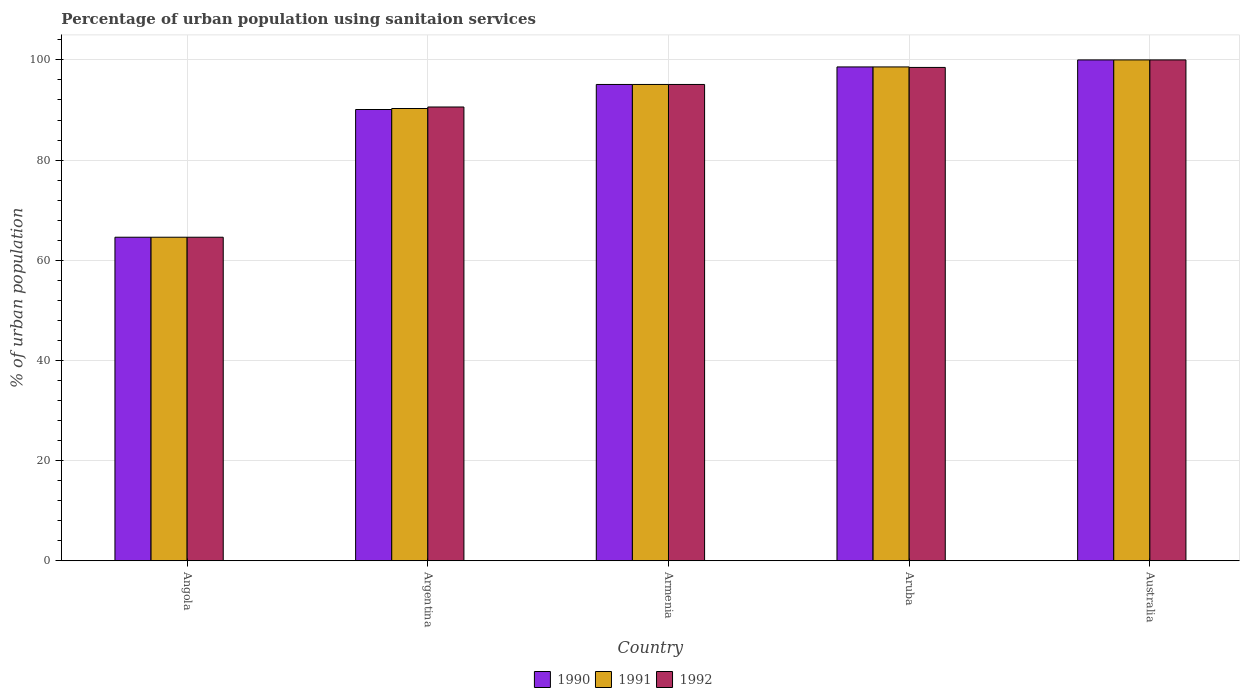How many different coloured bars are there?
Your answer should be very brief. 3. Are the number of bars per tick equal to the number of legend labels?
Your answer should be compact. Yes. Are the number of bars on each tick of the X-axis equal?
Your answer should be compact. Yes. How many bars are there on the 5th tick from the right?
Make the answer very short. 3. What is the label of the 2nd group of bars from the left?
Your response must be concise. Argentina. What is the percentage of urban population using sanitaion services in 1990 in Armenia?
Provide a short and direct response. 95.1. Across all countries, what is the maximum percentage of urban population using sanitaion services in 1990?
Give a very brief answer. 100. Across all countries, what is the minimum percentage of urban population using sanitaion services in 1990?
Offer a very short reply. 64.6. In which country was the percentage of urban population using sanitaion services in 1992 maximum?
Offer a very short reply. Australia. In which country was the percentage of urban population using sanitaion services in 1992 minimum?
Keep it short and to the point. Angola. What is the total percentage of urban population using sanitaion services in 1991 in the graph?
Give a very brief answer. 448.6. What is the difference between the percentage of urban population using sanitaion services in 1992 in Angola and that in Australia?
Your response must be concise. -35.4. What is the difference between the percentage of urban population using sanitaion services in 1990 in Argentina and the percentage of urban population using sanitaion services in 1992 in Angola?
Provide a short and direct response. 25.5. What is the average percentage of urban population using sanitaion services in 1992 per country?
Your answer should be compact. 89.76. What is the difference between the percentage of urban population using sanitaion services of/in 1990 and percentage of urban population using sanitaion services of/in 1992 in Argentina?
Offer a very short reply. -0.5. In how many countries, is the percentage of urban population using sanitaion services in 1991 greater than 56 %?
Keep it short and to the point. 5. What is the ratio of the percentage of urban population using sanitaion services in 1990 in Argentina to that in Australia?
Your answer should be very brief. 0.9. Is the percentage of urban population using sanitaion services in 1990 in Angola less than that in Armenia?
Your response must be concise. Yes. Is the difference between the percentage of urban population using sanitaion services in 1990 in Argentina and Aruba greater than the difference between the percentage of urban population using sanitaion services in 1992 in Argentina and Aruba?
Provide a succinct answer. No. What is the difference between the highest and the second highest percentage of urban population using sanitaion services in 1990?
Ensure brevity in your answer.  -1.4. What is the difference between the highest and the lowest percentage of urban population using sanitaion services in 1990?
Keep it short and to the point. 35.4. Are all the bars in the graph horizontal?
Keep it short and to the point. No. How many countries are there in the graph?
Keep it short and to the point. 5. Does the graph contain grids?
Keep it short and to the point. Yes. Where does the legend appear in the graph?
Keep it short and to the point. Bottom center. What is the title of the graph?
Make the answer very short. Percentage of urban population using sanitaion services. Does "1984" appear as one of the legend labels in the graph?
Ensure brevity in your answer.  No. What is the label or title of the Y-axis?
Make the answer very short. % of urban population. What is the % of urban population of 1990 in Angola?
Make the answer very short. 64.6. What is the % of urban population of 1991 in Angola?
Keep it short and to the point. 64.6. What is the % of urban population of 1992 in Angola?
Provide a succinct answer. 64.6. What is the % of urban population in 1990 in Argentina?
Offer a terse response. 90.1. What is the % of urban population in 1991 in Argentina?
Your answer should be compact. 90.3. What is the % of urban population of 1992 in Argentina?
Keep it short and to the point. 90.6. What is the % of urban population in 1990 in Armenia?
Offer a very short reply. 95.1. What is the % of urban population in 1991 in Armenia?
Keep it short and to the point. 95.1. What is the % of urban population in 1992 in Armenia?
Give a very brief answer. 95.1. What is the % of urban population of 1990 in Aruba?
Your answer should be compact. 98.6. What is the % of urban population in 1991 in Aruba?
Your answer should be compact. 98.6. What is the % of urban population of 1992 in Aruba?
Your answer should be very brief. 98.5. What is the % of urban population in 1990 in Australia?
Make the answer very short. 100. What is the % of urban population in 1991 in Australia?
Offer a very short reply. 100. Across all countries, what is the maximum % of urban population of 1990?
Provide a succinct answer. 100. Across all countries, what is the maximum % of urban population of 1991?
Offer a very short reply. 100. Across all countries, what is the maximum % of urban population of 1992?
Your response must be concise. 100. Across all countries, what is the minimum % of urban population in 1990?
Provide a succinct answer. 64.6. Across all countries, what is the minimum % of urban population of 1991?
Your answer should be compact. 64.6. Across all countries, what is the minimum % of urban population in 1992?
Your answer should be compact. 64.6. What is the total % of urban population in 1990 in the graph?
Provide a succinct answer. 448.4. What is the total % of urban population in 1991 in the graph?
Your response must be concise. 448.6. What is the total % of urban population in 1992 in the graph?
Your answer should be very brief. 448.8. What is the difference between the % of urban population of 1990 in Angola and that in Argentina?
Provide a succinct answer. -25.5. What is the difference between the % of urban population of 1991 in Angola and that in Argentina?
Keep it short and to the point. -25.7. What is the difference between the % of urban population in 1992 in Angola and that in Argentina?
Offer a very short reply. -26. What is the difference between the % of urban population of 1990 in Angola and that in Armenia?
Your response must be concise. -30.5. What is the difference between the % of urban population in 1991 in Angola and that in Armenia?
Your response must be concise. -30.5. What is the difference between the % of urban population of 1992 in Angola and that in Armenia?
Your answer should be very brief. -30.5. What is the difference between the % of urban population of 1990 in Angola and that in Aruba?
Offer a terse response. -34. What is the difference between the % of urban population in 1991 in Angola and that in Aruba?
Ensure brevity in your answer.  -34. What is the difference between the % of urban population in 1992 in Angola and that in Aruba?
Your answer should be compact. -33.9. What is the difference between the % of urban population of 1990 in Angola and that in Australia?
Keep it short and to the point. -35.4. What is the difference between the % of urban population of 1991 in Angola and that in Australia?
Make the answer very short. -35.4. What is the difference between the % of urban population of 1992 in Angola and that in Australia?
Give a very brief answer. -35.4. What is the difference between the % of urban population of 1991 in Argentina and that in Armenia?
Keep it short and to the point. -4.8. What is the difference between the % of urban population of 1992 in Argentina and that in Armenia?
Ensure brevity in your answer.  -4.5. What is the difference between the % of urban population in 1990 in Argentina and that in Aruba?
Provide a short and direct response. -8.5. What is the difference between the % of urban population of 1991 in Argentina and that in Aruba?
Your answer should be very brief. -8.3. What is the difference between the % of urban population of 1992 in Argentina and that in Aruba?
Your response must be concise. -7.9. What is the difference between the % of urban population in 1990 in Armenia and that in Australia?
Offer a terse response. -4.9. What is the difference between the % of urban population of 1991 in Armenia and that in Australia?
Make the answer very short. -4.9. What is the difference between the % of urban population in 1992 in Armenia and that in Australia?
Provide a short and direct response. -4.9. What is the difference between the % of urban population in 1990 in Aruba and that in Australia?
Ensure brevity in your answer.  -1.4. What is the difference between the % of urban population in 1991 in Aruba and that in Australia?
Offer a very short reply. -1.4. What is the difference between the % of urban population of 1992 in Aruba and that in Australia?
Provide a succinct answer. -1.5. What is the difference between the % of urban population of 1990 in Angola and the % of urban population of 1991 in Argentina?
Make the answer very short. -25.7. What is the difference between the % of urban population in 1991 in Angola and the % of urban population in 1992 in Argentina?
Provide a short and direct response. -26. What is the difference between the % of urban population of 1990 in Angola and the % of urban population of 1991 in Armenia?
Provide a succinct answer. -30.5. What is the difference between the % of urban population of 1990 in Angola and the % of urban population of 1992 in Armenia?
Provide a short and direct response. -30.5. What is the difference between the % of urban population of 1991 in Angola and the % of urban population of 1992 in Armenia?
Your answer should be very brief. -30.5. What is the difference between the % of urban population of 1990 in Angola and the % of urban population of 1991 in Aruba?
Make the answer very short. -34. What is the difference between the % of urban population in 1990 in Angola and the % of urban population in 1992 in Aruba?
Your response must be concise. -33.9. What is the difference between the % of urban population in 1991 in Angola and the % of urban population in 1992 in Aruba?
Provide a short and direct response. -33.9. What is the difference between the % of urban population of 1990 in Angola and the % of urban population of 1991 in Australia?
Offer a very short reply. -35.4. What is the difference between the % of urban population of 1990 in Angola and the % of urban population of 1992 in Australia?
Offer a very short reply. -35.4. What is the difference between the % of urban population in 1991 in Angola and the % of urban population in 1992 in Australia?
Make the answer very short. -35.4. What is the difference between the % of urban population of 1990 in Argentina and the % of urban population of 1991 in Armenia?
Give a very brief answer. -5. What is the difference between the % of urban population in 1990 in Argentina and the % of urban population in 1992 in Armenia?
Your response must be concise. -5. What is the difference between the % of urban population of 1990 in Argentina and the % of urban population of 1991 in Aruba?
Your response must be concise. -8.5. What is the difference between the % of urban population of 1990 in Armenia and the % of urban population of 1992 in Aruba?
Provide a succinct answer. -3.4. What is the difference between the % of urban population of 1991 in Armenia and the % of urban population of 1992 in Aruba?
Your answer should be compact. -3.4. What is the difference between the % of urban population in 1990 in Armenia and the % of urban population in 1992 in Australia?
Provide a succinct answer. -4.9. What is the difference between the % of urban population of 1990 in Aruba and the % of urban population of 1992 in Australia?
Offer a terse response. -1.4. What is the average % of urban population in 1990 per country?
Provide a succinct answer. 89.68. What is the average % of urban population of 1991 per country?
Make the answer very short. 89.72. What is the average % of urban population of 1992 per country?
Provide a succinct answer. 89.76. What is the difference between the % of urban population in 1990 and % of urban population in 1992 in Angola?
Offer a terse response. 0. What is the difference between the % of urban population in 1990 and % of urban population in 1991 in Argentina?
Make the answer very short. -0.2. What is the difference between the % of urban population in 1991 and % of urban population in 1992 in Argentina?
Provide a short and direct response. -0.3. What is the difference between the % of urban population of 1990 and % of urban population of 1991 in Armenia?
Provide a short and direct response. 0. What is the difference between the % of urban population in 1990 and % of urban population in 1992 in Armenia?
Your answer should be compact. 0. What is the difference between the % of urban population in 1991 and % of urban population in 1992 in Armenia?
Your response must be concise. 0. What is the difference between the % of urban population in 1990 and % of urban population in 1992 in Aruba?
Give a very brief answer. 0.1. What is the difference between the % of urban population in 1991 and % of urban population in 1992 in Australia?
Offer a very short reply. 0. What is the ratio of the % of urban population in 1990 in Angola to that in Argentina?
Provide a short and direct response. 0.72. What is the ratio of the % of urban population of 1991 in Angola to that in Argentina?
Offer a terse response. 0.72. What is the ratio of the % of urban population in 1992 in Angola to that in Argentina?
Keep it short and to the point. 0.71. What is the ratio of the % of urban population in 1990 in Angola to that in Armenia?
Ensure brevity in your answer.  0.68. What is the ratio of the % of urban population in 1991 in Angola to that in Armenia?
Your response must be concise. 0.68. What is the ratio of the % of urban population of 1992 in Angola to that in Armenia?
Offer a very short reply. 0.68. What is the ratio of the % of urban population in 1990 in Angola to that in Aruba?
Your response must be concise. 0.66. What is the ratio of the % of urban population of 1991 in Angola to that in Aruba?
Provide a succinct answer. 0.66. What is the ratio of the % of urban population of 1992 in Angola to that in Aruba?
Give a very brief answer. 0.66. What is the ratio of the % of urban population in 1990 in Angola to that in Australia?
Provide a short and direct response. 0.65. What is the ratio of the % of urban population in 1991 in Angola to that in Australia?
Keep it short and to the point. 0.65. What is the ratio of the % of urban population in 1992 in Angola to that in Australia?
Provide a succinct answer. 0.65. What is the ratio of the % of urban population in 1990 in Argentina to that in Armenia?
Offer a terse response. 0.95. What is the ratio of the % of urban population in 1991 in Argentina to that in Armenia?
Keep it short and to the point. 0.95. What is the ratio of the % of urban population of 1992 in Argentina to that in Armenia?
Make the answer very short. 0.95. What is the ratio of the % of urban population of 1990 in Argentina to that in Aruba?
Make the answer very short. 0.91. What is the ratio of the % of urban population of 1991 in Argentina to that in Aruba?
Ensure brevity in your answer.  0.92. What is the ratio of the % of urban population of 1992 in Argentina to that in Aruba?
Offer a very short reply. 0.92. What is the ratio of the % of urban population of 1990 in Argentina to that in Australia?
Make the answer very short. 0.9. What is the ratio of the % of urban population in 1991 in Argentina to that in Australia?
Give a very brief answer. 0.9. What is the ratio of the % of urban population of 1992 in Argentina to that in Australia?
Provide a short and direct response. 0.91. What is the ratio of the % of urban population of 1990 in Armenia to that in Aruba?
Keep it short and to the point. 0.96. What is the ratio of the % of urban population of 1991 in Armenia to that in Aruba?
Offer a very short reply. 0.96. What is the ratio of the % of urban population of 1992 in Armenia to that in Aruba?
Make the answer very short. 0.97. What is the ratio of the % of urban population in 1990 in Armenia to that in Australia?
Ensure brevity in your answer.  0.95. What is the ratio of the % of urban population of 1991 in Armenia to that in Australia?
Ensure brevity in your answer.  0.95. What is the ratio of the % of urban population of 1992 in Armenia to that in Australia?
Your answer should be very brief. 0.95. What is the ratio of the % of urban population of 1991 in Aruba to that in Australia?
Provide a short and direct response. 0.99. What is the difference between the highest and the second highest % of urban population of 1991?
Make the answer very short. 1.4. What is the difference between the highest and the second highest % of urban population of 1992?
Make the answer very short. 1.5. What is the difference between the highest and the lowest % of urban population of 1990?
Provide a short and direct response. 35.4. What is the difference between the highest and the lowest % of urban population of 1991?
Offer a terse response. 35.4. What is the difference between the highest and the lowest % of urban population in 1992?
Your answer should be compact. 35.4. 